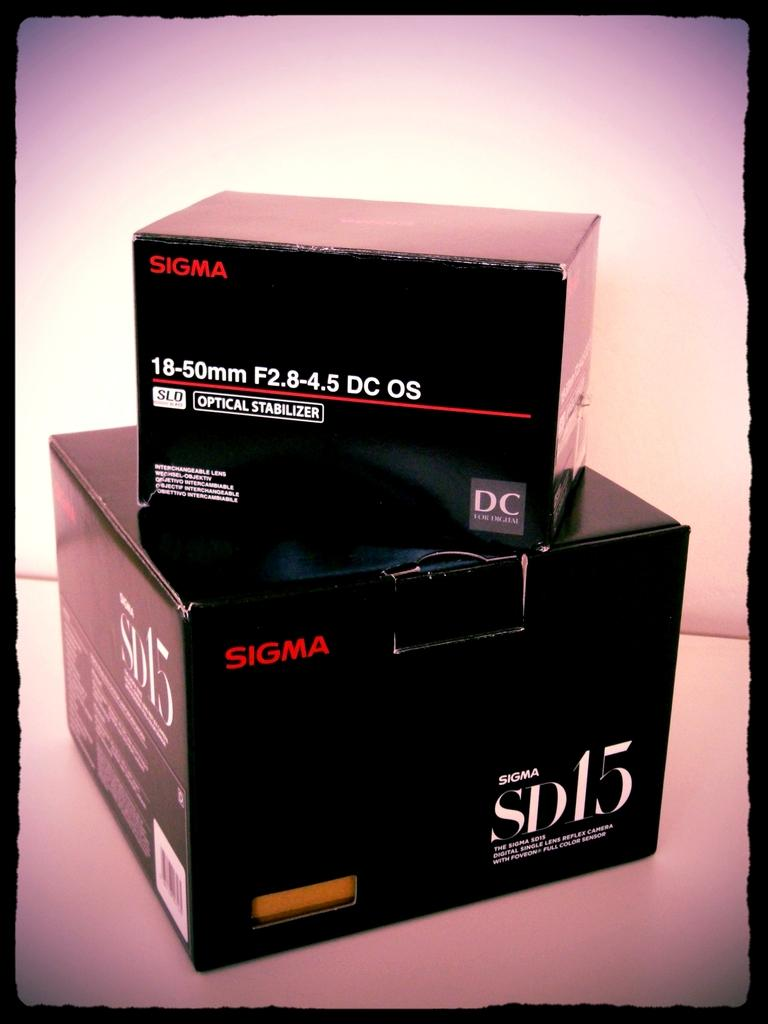What objects are present in the image? There are two cardboard boxes in the image. What is the color of the surface on which the boxes are placed? The boxes are on a white surface. What can be found on the boxes? There is text on the boxes. How many brains can be seen inside the cardboard boxes in the image? There are no brains visible in the image; it features two cardboard boxes with text on them. 